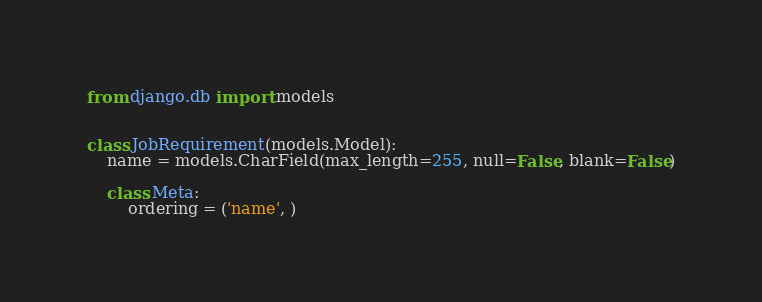Convert code to text. <code><loc_0><loc_0><loc_500><loc_500><_Python_>from django.db import models


class JobRequirement(models.Model):
    name = models.CharField(max_length=255, null=False, blank=False)

    class Meta:
        ordering = ('name', )
</code> 